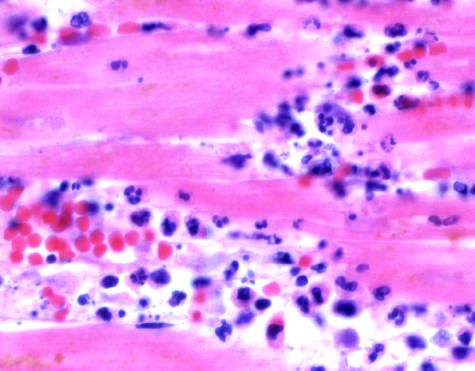what show an inflammatory reaction in the myocardium after ischemic necrosis infarction?
Answer the question using a single word or phrase. The photomicrographs 